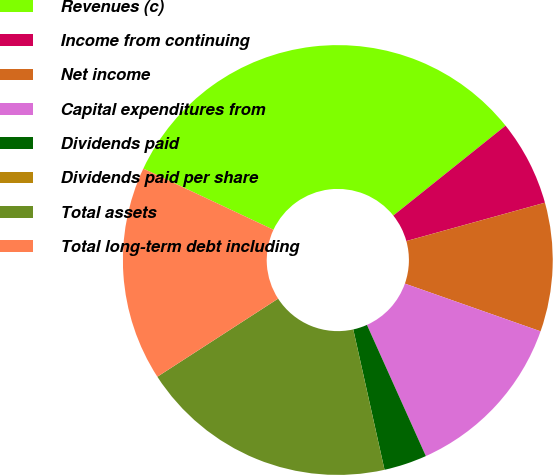<chart> <loc_0><loc_0><loc_500><loc_500><pie_chart><fcel>Revenues (c)<fcel>Income from continuing<fcel>Net income<fcel>Capital expenditures from<fcel>Dividends paid<fcel>Dividends paid per share<fcel>Total assets<fcel>Total long-term debt including<nl><fcel>32.26%<fcel>6.45%<fcel>9.68%<fcel>12.9%<fcel>3.23%<fcel>0.0%<fcel>19.35%<fcel>16.13%<nl></chart> 